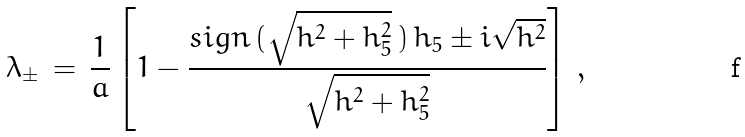Convert formula to latex. <formula><loc_0><loc_0><loc_500><loc_500>\lambda _ { \pm } \, = \, \frac { 1 } { a } \left [ 1 - \frac { s i g n \, ( \sqrt { h ^ { 2 } + h _ { 5 } ^ { 2 } } \, ) \, h _ { 5 } \pm i \sqrt { h ^ { 2 } } } { \sqrt { h ^ { 2 } + h _ { 5 } ^ { 2 } } } \right ] \, ,</formula> 